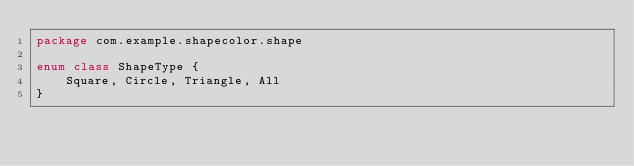Convert code to text. <code><loc_0><loc_0><loc_500><loc_500><_Kotlin_>package com.example.shapecolor.shape

enum class ShapeType {
    Square, Circle, Triangle, All
}</code> 